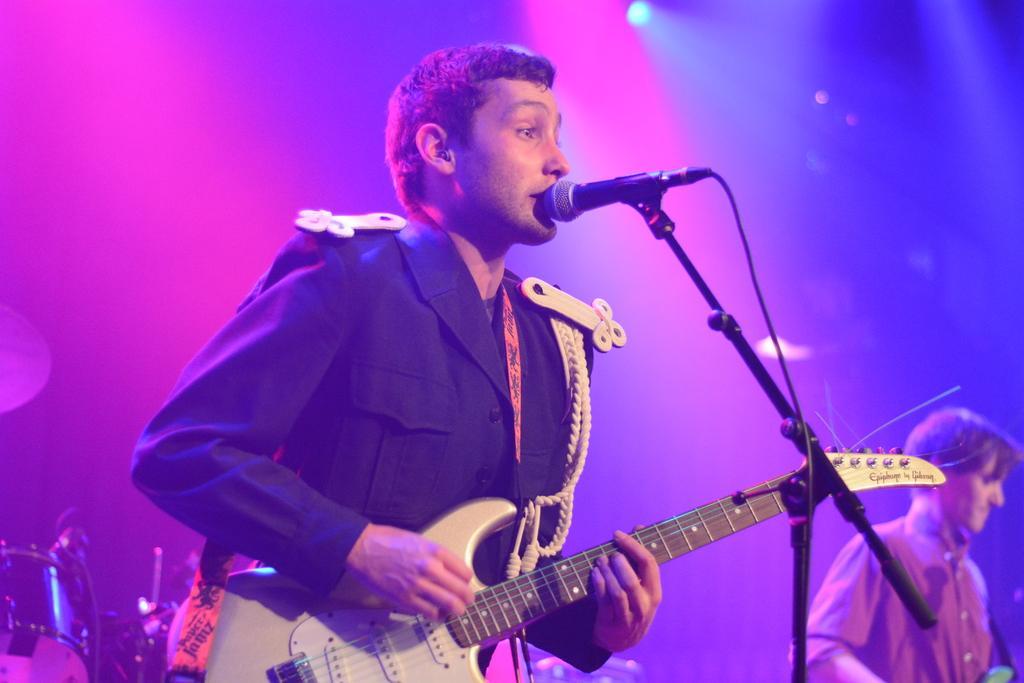Can you describe this image briefly? This is the picture of a person in black dress holding a guitar and playing it in front of the mic and beside there is an another person behind there is a drum. 